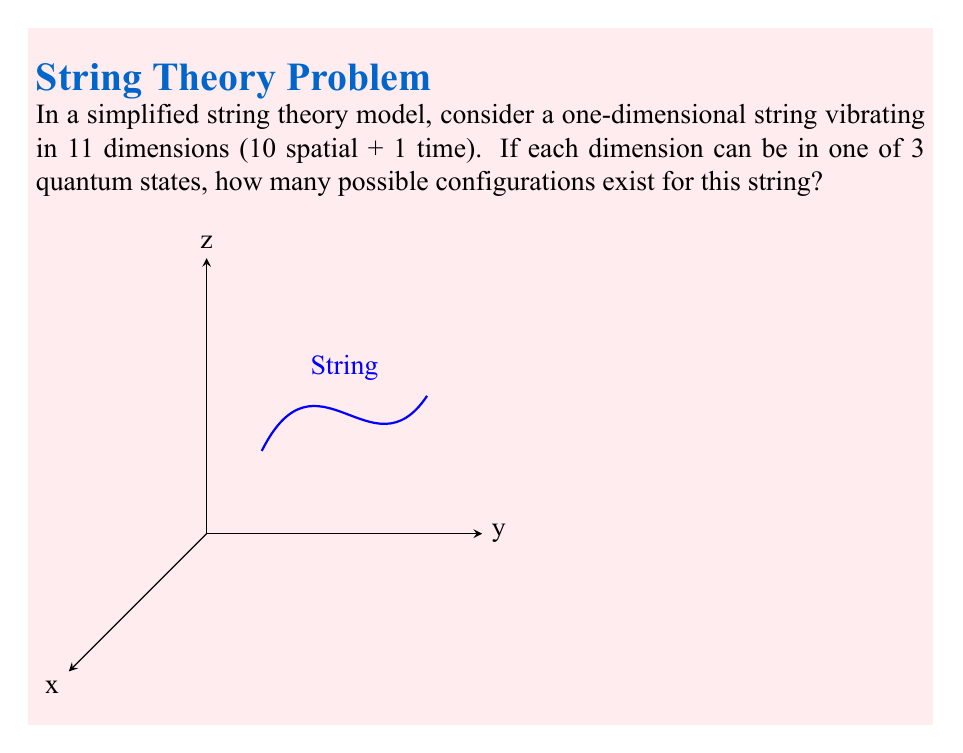Solve this math problem. Let's approach this step-by-step:

1) We have a string vibrating in 11 dimensions (10 spatial + 1 time).

2) Each dimension can be in one of 3 quantum states.

3) For each dimension, we have 3 choices, independent of the other dimensions.

4) This scenario can be modeled using the fundamental counting principle.

5) The fundamental counting principle states that if we have $n$ independent events, and each event $i$ has $m_i$ possible outcomes, then the total number of possible outcomes for all events is:

   $$\prod_{i=1}^n m_i$$

6) In our case, we have 11 dimensions (n = 11), and each dimension has 3 possible states (m_i = 3 for all i).

7) Therefore, the total number of possible configurations is:

   $$3^{11} = 3 \times 3 \times 3 \times ... \times 3 \text{ (11 times)}$$

8) Calculating this:

   $$3^{11} = 177,147$$

Thus, there are 177,147 possible configurations for this string.
Answer: $3^{11} = 177,147$ 